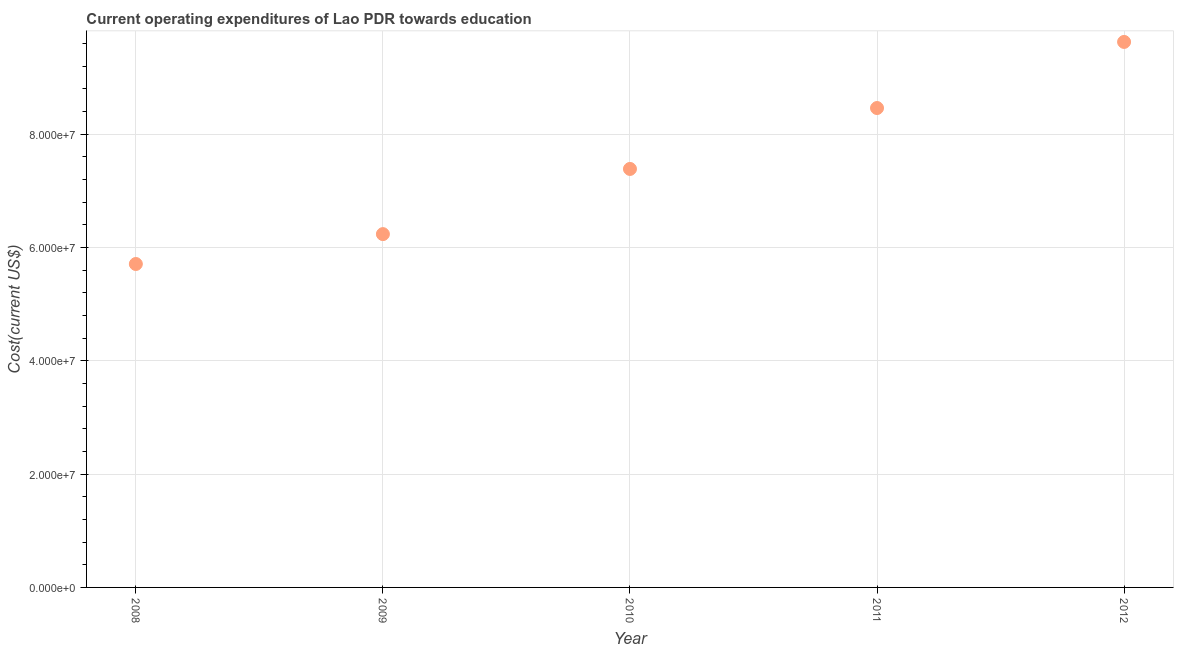What is the education expenditure in 2012?
Give a very brief answer. 9.63e+07. Across all years, what is the maximum education expenditure?
Provide a short and direct response. 9.63e+07. Across all years, what is the minimum education expenditure?
Keep it short and to the point. 5.71e+07. In which year was the education expenditure maximum?
Give a very brief answer. 2012. What is the sum of the education expenditure?
Give a very brief answer. 3.74e+08. What is the difference between the education expenditure in 2009 and 2012?
Give a very brief answer. -3.39e+07. What is the average education expenditure per year?
Your response must be concise. 7.48e+07. What is the median education expenditure?
Offer a very short reply. 7.38e+07. Do a majority of the years between 2009 and 2008 (inclusive) have education expenditure greater than 92000000 US$?
Give a very brief answer. No. What is the ratio of the education expenditure in 2008 to that in 2012?
Keep it short and to the point. 0.59. Is the difference between the education expenditure in 2010 and 2011 greater than the difference between any two years?
Keep it short and to the point. No. What is the difference between the highest and the second highest education expenditure?
Your answer should be very brief. 1.17e+07. Is the sum of the education expenditure in 2008 and 2012 greater than the maximum education expenditure across all years?
Make the answer very short. Yes. What is the difference between the highest and the lowest education expenditure?
Provide a short and direct response. 3.92e+07. Does the education expenditure monotonically increase over the years?
Your answer should be very brief. Yes. How many dotlines are there?
Your answer should be very brief. 1. How many years are there in the graph?
Your answer should be very brief. 5. Are the values on the major ticks of Y-axis written in scientific E-notation?
Provide a short and direct response. Yes. Does the graph contain any zero values?
Your answer should be very brief. No. Does the graph contain grids?
Provide a succinct answer. Yes. What is the title of the graph?
Ensure brevity in your answer.  Current operating expenditures of Lao PDR towards education. What is the label or title of the X-axis?
Offer a terse response. Year. What is the label or title of the Y-axis?
Provide a succinct answer. Cost(current US$). What is the Cost(current US$) in 2008?
Offer a terse response. 5.71e+07. What is the Cost(current US$) in 2009?
Offer a terse response. 6.23e+07. What is the Cost(current US$) in 2010?
Your response must be concise. 7.38e+07. What is the Cost(current US$) in 2011?
Your answer should be very brief. 8.46e+07. What is the Cost(current US$) in 2012?
Offer a very short reply. 9.63e+07. What is the difference between the Cost(current US$) in 2008 and 2009?
Offer a very short reply. -5.27e+06. What is the difference between the Cost(current US$) in 2008 and 2010?
Provide a short and direct response. -1.68e+07. What is the difference between the Cost(current US$) in 2008 and 2011?
Your answer should be compact. -2.75e+07. What is the difference between the Cost(current US$) in 2008 and 2012?
Give a very brief answer. -3.92e+07. What is the difference between the Cost(current US$) in 2009 and 2010?
Your answer should be very brief. -1.15e+07. What is the difference between the Cost(current US$) in 2009 and 2011?
Your answer should be compact. -2.22e+07. What is the difference between the Cost(current US$) in 2009 and 2012?
Your answer should be very brief. -3.39e+07. What is the difference between the Cost(current US$) in 2010 and 2011?
Keep it short and to the point. -1.07e+07. What is the difference between the Cost(current US$) in 2010 and 2012?
Your answer should be compact. -2.24e+07. What is the difference between the Cost(current US$) in 2011 and 2012?
Your answer should be compact. -1.17e+07. What is the ratio of the Cost(current US$) in 2008 to that in 2009?
Offer a terse response. 0.92. What is the ratio of the Cost(current US$) in 2008 to that in 2010?
Provide a short and direct response. 0.77. What is the ratio of the Cost(current US$) in 2008 to that in 2011?
Give a very brief answer. 0.68. What is the ratio of the Cost(current US$) in 2008 to that in 2012?
Give a very brief answer. 0.59. What is the ratio of the Cost(current US$) in 2009 to that in 2010?
Your answer should be very brief. 0.84. What is the ratio of the Cost(current US$) in 2009 to that in 2011?
Give a very brief answer. 0.74. What is the ratio of the Cost(current US$) in 2009 to that in 2012?
Ensure brevity in your answer.  0.65. What is the ratio of the Cost(current US$) in 2010 to that in 2011?
Offer a terse response. 0.87. What is the ratio of the Cost(current US$) in 2010 to that in 2012?
Ensure brevity in your answer.  0.77. What is the ratio of the Cost(current US$) in 2011 to that in 2012?
Offer a terse response. 0.88. 